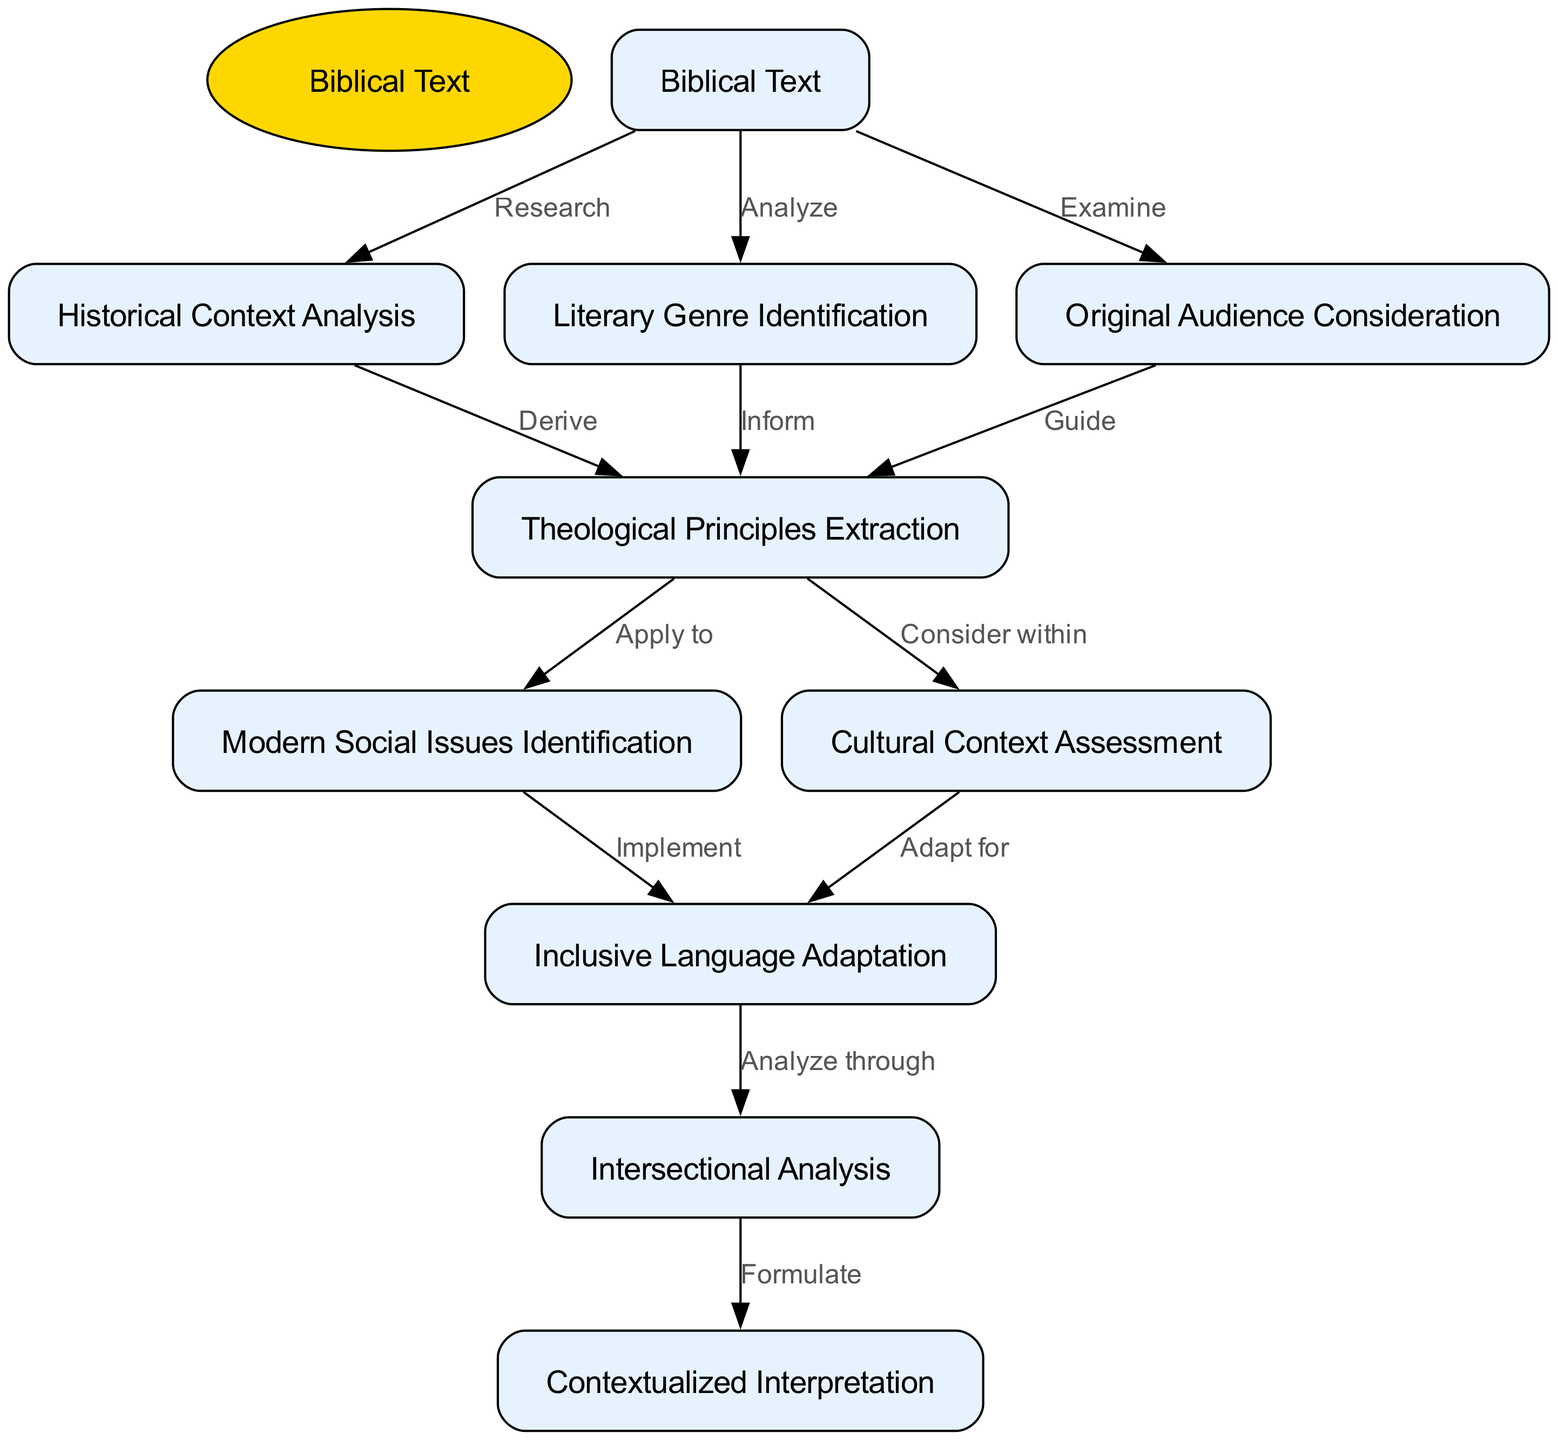What is the starting point of the flowchart? The starting point, labeled as the "Biblical Text," is the first and central node in the flowchart from which all subsequent processes branch out.
Answer: Biblical Text How many nodes are there in total? Counting all the nodes including the start node, there are ten nodes: one start node and nine additional nodes representing various processes.
Answer: Ten What is the action described from "Biblical Text" to "Historical Context Analysis"? The action connecting "Biblical Text" to "Historical Context Analysis" is labeled as "Research," indicating the nature of the initial engagement with the biblical text.
Answer: Research Which two nodes have the action "Guide" connecting them? The nodes that have the action "Guide" connecting them are "Original Audience Consideration" and "Theological Principles Extraction," indicating that understanding the original audience helps guide the extraction of theological principles.
Answer: Original Audience Consideration and Theological Principles Extraction What is the last node in the flowchart? The last node is "Contextualized Interpretation," which signifies the final step where all previous analyses culminate into an interpretation that relates to contemporary issues and contexts.
Answer: Contextualized Interpretation Which node connects to "Inclusive Language Adaptation" through the action of "Implement"? The node that connects to "Inclusive Language Adaptation" via the action "Implement" is "Modern Social Issues Identification," representing that once social issues are identified, inclusive language is then adapted accordingly.
Answer: Modern Social Issues Identification What is the relationship between "Cultural Context Assessment" and "Inclusive Language Adaptation"? The relationship is marked by the action "Adapt for," indicating that after assessing cultural context, the biblical text is adapted to ensure inclusiveness in language.
Answer: Adapt for What action is taken from "Theological Principles Extraction" to "Modern Social Issues Identification"? The action taken is "Apply to," meaning the theological principles derived from the text are applied to identify relevant modern social issues.
Answer: Apply to Which part of the flowchart includes an analysis of diversity in perspectives? The part of the flowchart that involves an analysis of diversity in perspectives is represented by the node "Intersectional Analysis," which relates to how varying cultural contexts shape understanding and interpretation.
Answer: Intersectional Analysis 